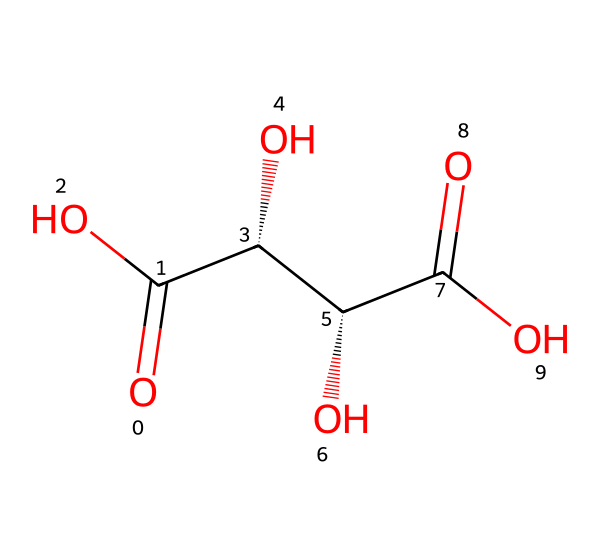What is the molecular formula of tartaric acid? To derive the molecular formula, count the carbon (C), hydrogen (H), and oxygen (O) atoms present in the chemical structure. There are 4 carbon atoms, 6 hydrogen atoms, and 5 oxygen atoms. Thus, the formula is C4H6O5.
Answer: C4H6O5 How many chiral centers are in tartaric acid? Chiral centers are typically carbon atoms bonded to four different groups. In the structure, we identify two carbon atoms that each are connected to four unique substituents: one is a hydroxyl group (OH), and the other is part of a carboxylic acid group (COOH). Therefore, there are two chiral centers.
Answer: 2 How many carboxylic acid groups are present? By analyzing the structure, we can see that there are two –OH groups that are part of carboxylic acid functionalities (represented as COOH), which confirms the presence of two carboxyl groups.
Answer: 2 What type of interaction can form due to the hydroxyl groups in tartaric acid? The hydroxyl groups (-OH) can form hydrogen bonds because they can act as hydrogen donors and acceptors in chemical interactions, contributing to the non-Newtonian properties in solution.
Answer: hydrogen bonds How does the structure of tartaric acid influence its crystallization in aged wines? The presence of multiple hydroxyl and carboxylic groups allows tartaric acid to form hydrogen bonds, which leads to a specific crystalline arrangement when precipitating out of solution. This organized crystal structure is crucial in defining the texture and stability of the wine.
Answer: hydrogen bonding What type of acid is tartaric acid classified as? Tartaric acid is classified as a dicarboxylic acid due to the presence of two carboxylic acid functional groups in its structure.
Answer: dicarboxylic acid 